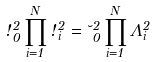Convert formula to latex. <formula><loc_0><loc_0><loc_500><loc_500>\omega _ { 0 } ^ { 2 } \prod _ { i = 1 } ^ { N } \omega _ { i } ^ { 2 } = \lambda _ { 0 } ^ { 2 } \prod _ { i = 1 } ^ { N } \Lambda _ { i } ^ { 2 }</formula> 